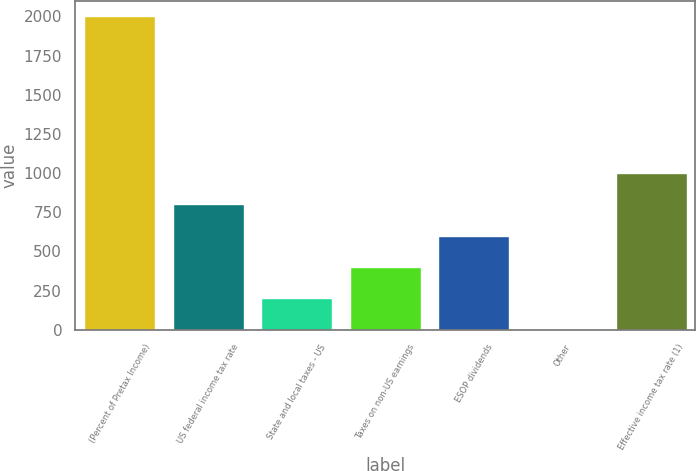Convert chart to OTSL. <chart><loc_0><loc_0><loc_500><loc_500><bar_chart><fcel>(Percent of Pretax Income)<fcel>US federal income tax rate<fcel>State and local taxes - US<fcel>Taxes on non-US earnings<fcel>ESOP dividends<fcel>Other<fcel>Effective income tax rate (1)<nl><fcel>2001<fcel>801.04<fcel>201.04<fcel>401.04<fcel>601.04<fcel>1.04<fcel>1001.04<nl></chart> 